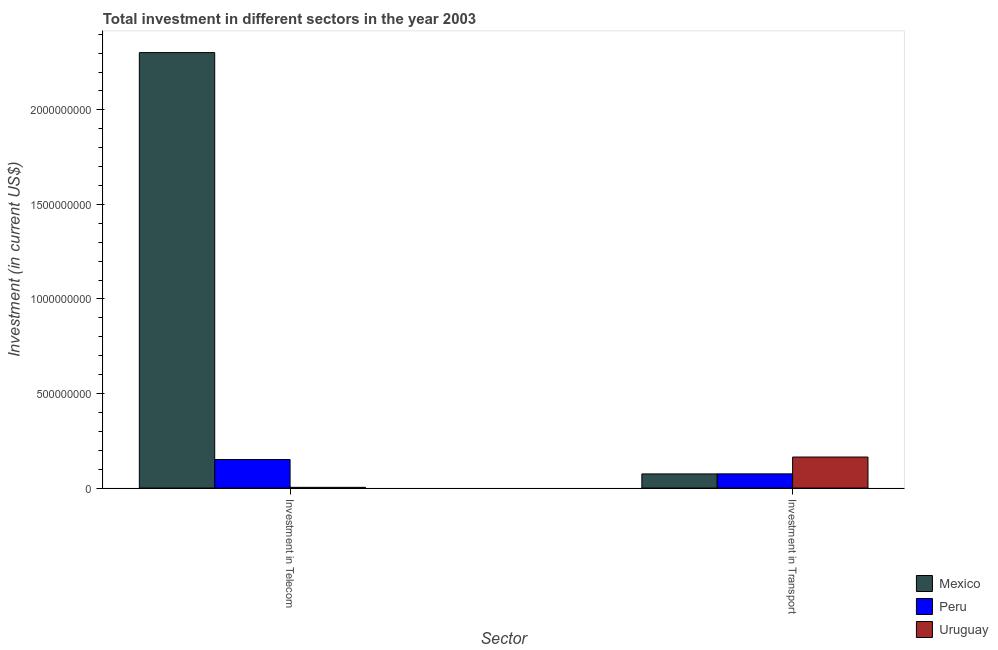Are the number of bars per tick equal to the number of legend labels?
Your response must be concise. Yes. How many bars are there on the 2nd tick from the left?
Give a very brief answer. 3. How many bars are there on the 2nd tick from the right?
Ensure brevity in your answer.  3. What is the label of the 2nd group of bars from the left?
Your response must be concise. Investment in Transport. What is the investment in transport in Peru?
Your answer should be compact. 7.50e+07. Across all countries, what is the maximum investment in telecom?
Your answer should be compact. 2.30e+09. Across all countries, what is the minimum investment in telecom?
Provide a succinct answer. 3.70e+06. In which country was the investment in transport maximum?
Give a very brief answer. Uruguay. What is the total investment in telecom in the graph?
Your answer should be compact. 2.46e+09. What is the difference between the investment in telecom in Uruguay and that in Peru?
Keep it short and to the point. -1.47e+08. What is the difference between the investment in transport in Mexico and the investment in telecom in Uruguay?
Offer a very short reply. 7.10e+07. What is the average investment in telecom per country?
Offer a very short reply. 8.19e+08. What is the difference between the investment in telecom and investment in transport in Peru?
Your response must be concise. 7.58e+07. In how many countries, is the investment in transport greater than 100000000 US$?
Ensure brevity in your answer.  1. What is the ratio of the investment in telecom in Uruguay to that in Peru?
Provide a short and direct response. 0.02. Is the investment in transport in Mexico less than that in Uruguay?
Make the answer very short. Yes. What does the 3rd bar from the left in Investment in Telecom represents?
Ensure brevity in your answer.  Uruguay. How many bars are there?
Offer a very short reply. 6. How many countries are there in the graph?
Offer a very short reply. 3. Are the values on the major ticks of Y-axis written in scientific E-notation?
Offer a very short reply. No. How many legend labels are there?
Your response must be concise. 3. How are the legend labels stacked?
Your answer should be compact. Vertical. What is the title of the graph?
Offer a terse response. Total investment in different sectors in the year 2003. Does "Canada" appear as one of the legend labels in the graph?
Provide a succinct answer. No. What is the label or title of the X-axis?
Offer a very short reply. Sector. What is the label or title of the Y-axis?
Your answer should be very brief. Investment (in current US$). What is the Investment (in current US$) in Mexico in Investment in Telecom?
Ensure brevity in your answer.  2.30e+09. What is the Investment (in current US$) in Peru in Investment in Telecom?
Ensure brevity in your answer.  1.51e+08. What is the Investment (in current US$) in Uruguay in Investment in Telecom?
Offer a terse response. 3.70e+06. What is the Investment (in current US$) of Mexico in Investment in Transport?
Make the answer very short. 7.47e+07. What is the Investment (in current US$) of Peru in Investment in Transport?
Provide a short and direct response. 7.50e+07. What is the Investment (in current US$) of Uruguay in Investment in Transport?
Your answer should be compact. 1.64e+08. Across all Sector, what is the maximum Investment (in current US$) of Mexico?
Make the answer very short. 2.30e+09. Across all Sector, what is the maximum Investment (in current US$) of Peru?
Offer a terse response. 1.51e+08. Across all Sector, what is the maximum Investment (in current US$) of Uruguay?
Provide a succinct answer. 1.64e+08. Across all Sector, what is the minimum Investment (in current US$) of Mexico?
Make the answer very short. 7.47e+07. Across all Sector, what is the minimum Investment (in current US$) in Peru?
Make the answer very short. 7.50e+07. Across all Sector, what is the minimum Investment (in current US$) of Uruguay?
Make the answer very short. 3.70e+06. What is the total Investment (in current US$) of Mexico in the graph?
Give a very brief answer. 2.38e+09. What is the total Investment (in current US$) in Peru in the graph?
Offer a terse response. 2.26e+08. What is the total Investment (in current US$) of Uruguay in the graph?
Provide a short and direct response. 1.68e+08. What is the difference between the Investment (in current US$) in Mexico in Investment in Telecom and that in Investment in Transport?
Your answer should be compact. 2.23e+09. What is the difference between the Investment (in current US$) in Peru in Investment in Telecom and that in Investment in Transport?
Give a very brief answer. 7.58e+07. What is the difference between the Investment (in current US$) of Uruguay in Investment in Telecom and that in Investment in Transport?
Your response must be concise. -1.60e+08. What is the difference between the Investment (in current US$) of Mexico in Investment in Telecom and the Investment (in current US$) of Peru in Investment in Transport?
Make the answer very short. 2.23e+09. What is the difference between the Investment (in current US$) of Mexico in Investment in Telecom and the Investment (in current US$) of Uruguay in Investment in Transport?
Make the answer very short. 2.14e+09. What is the difference between the Investment (in current US$) in Peru in Investment in Telecom and the Investment (in current US$) in Uruguay in Investment in Transport?
Your answer should be very brief. -1.32e+07. What is the average Investment (in current US$) of Mexico per Sector?
Your answer should be very brief. 1.19e+09. What is the average Investment (in current US$) in Peru per Sector?
Provide a succinct answer. 1.13e+08. What is the average Investment (in current US$) in Uruguay per Sector?
Ensure brevity in your answer.  8.38e+07. What is the difference between the Investment (in current US$) of Mexico and Investment (in current US$) of Peru in Investment in Telecom?
Your answer should be compact. 2.15e+09. What is the difference between the Investment (in current US$) of Mexico and Investment (in current US$) of Uruguay in Investment in Telecom?
Offer a terse response. 2.30e+09. What is the difference between the Investment (in current US$) of Peru and Investment (in current US$) of Uruguay in Investment in Telecom?
Your answer should be very brief. 1.47e+08. What is the difference between the Investment (in current US$) in Mexico and Investment (in current US$) in Peru in Investment in Transport?
Offer a very short reply. -3.00e+05. What is the difference between the Investment (in current US$) in Mexico and Investment (in current US$) in Uruguay in Investment in Transport?
Your response must be concise. -8.93e+07. What is the difference between the Investment (in current US$) of Peru and Investment (in current US$) of Uruguay in Investment in Transport?
Give a very brief answer. -8.90e+07. What is the ratio of the Investment (in current US$) in Mexico in Investment in Telecom to that in Investment in Transport?
Offer a very short reply. 30.83. What is the ratio of the Investment (in current US$) in Peru in Investment in Telecom to that in Investment in Transport?
Make the answer very short. 2.01. What is the ratio of the Investment (in current US$) in Uruguay in Investment in Telecom to that in Investment in Transport?
Give a very brief answer. 0.02. What is the difference between the highest and the second highest Investment (in current US$) in Mexico?
Ensure brevity in your answer.  2.23e+09. What is the difference between the highest and the second highest Investment (in current US$) of Peru?
Ensure brevity in your answer.  7.58e+07. What is the difference between the highest and the second highest Investment (in current US$) in Uruguay?
Offer a very short reply. 1.60e+08. What is the difference between the highest and the lowest Investment (in current US$) of Mexico?
Give a very brief answer. 2.23e+09. What is the difference between the highest and the lowest Investment (in current US$) of Peru?
Give a very brief answer. 7.58e+07. What is the difference between the highest and the lowest Investment (in current US$) in Uruguay?
Offer a terse response. 1.60e+08. 